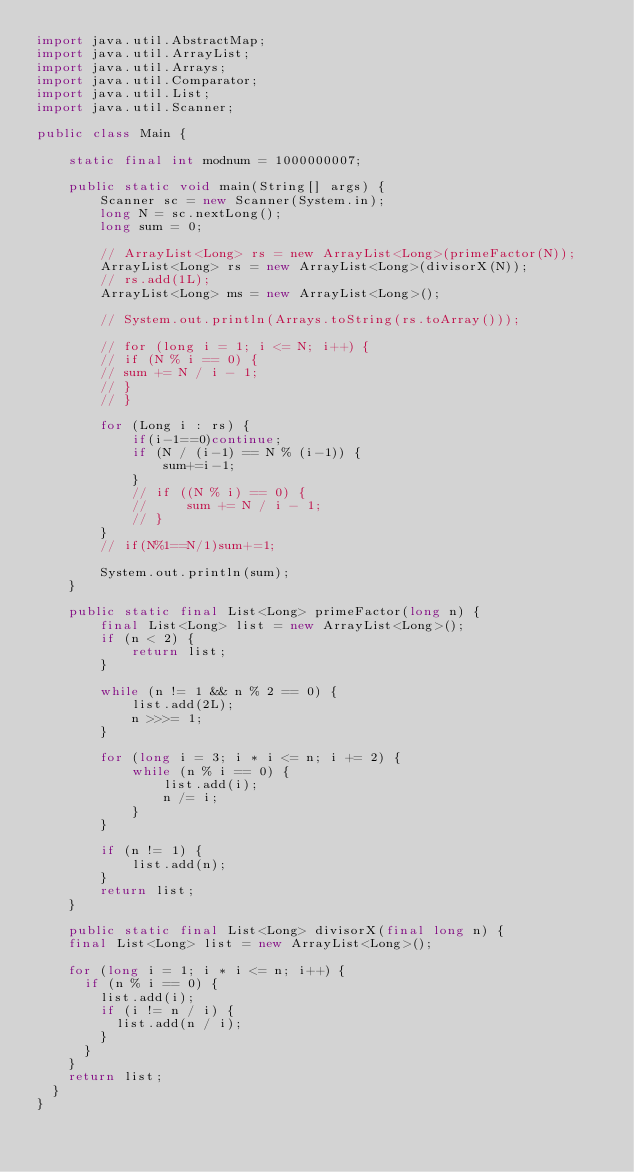<code> <loc_0><loc_0><loc_500><loc_500><_Java_>import java.util.AbstractMap;
import java.util.ArrayList;
import java.util.Arrays;
import java.util.Comparator;
import java.util.List;
import java.util.Scanner;

public class Main {

    static final int modnum = 1000000007;

    public static void main(String[] args) {
        Scanner sc = new Scanner(System.in);
        long N = sc.nextLong();
        long sum = 0;

        // ArrayList<Long> rs = new ArrayList<Long>(primeFactor(N));
        ArrayList<Long> rs = new ArrayList<Long>(divisorX(N));
        // rs.add(1L);
        ArrayList<Long> ms = new ArrayList<Long>();

        // System.out.println(Arrays.toString(rs.toArray()));

        // for (long i = 1; i <= N; i++) {
        // if (N % i == 0) {
        // sum += N / i - 1;
        // }
        // }

        for (Long i : rs) {
            if(i-1==0)continue;
            if (N / (i-1) == N % (i-1)) {
                sum+=i-1;
            }
            // if ((N % i) == 0) {
            //     sum += N / i - 1;
            // }
        }
        // if(N%1==N/1)sum+=1;

        System.out.println(sum);
    }

    public static final List<Long> primeFactor(long n) {
        final List<Long> list = new ArrayList<Long>();
        if (n < 2) {
            return list;
        }

        while (n != 1 && n % 2 == 0) {
            list.add(2L);
            n >>>= 1;
        }

        for (long i = 3; i * i <= n; i += 2) {
            while (n % i == 0) {
                list.add(i);
                n /= i;
            }
        }

        if (n != 1) {
            list.add(n);
        }
        return list;
    }

    public static final List<Long> divisorX(final long n) {
		final List<Long> list = new ArrayList<Long>();

		for (long i = 1; i * i <= n; i++) {
			if (n % i == 0) {
				list.add(i);
				if (i != n / i) {
					list.add(n / i);
				}
			}
		}
		return list;
	}
}
</code> 